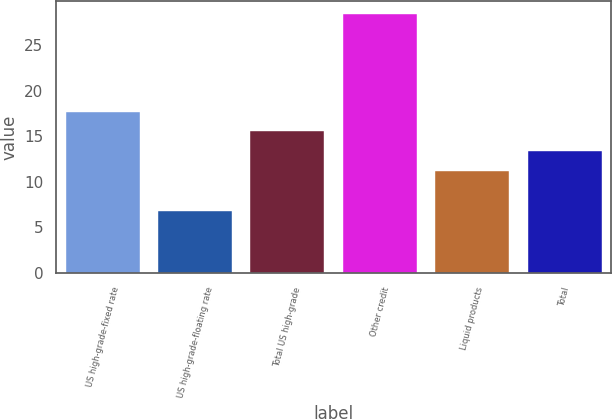<chart> <loc_0><loc_0><loc_500><loc_500><bar_chart><fcel>US high-grade-fixed rate<fcel>US high-grade-floating rate<fcel>Total US high-grade<fcel>Other credit<fcel>Liquid products<fcel>Total<nl><fcel>17.68<fcel>6.8<fcel>15.52<fcel>28.4<fcel>11.2<fcel>13.36<nl></chart> 